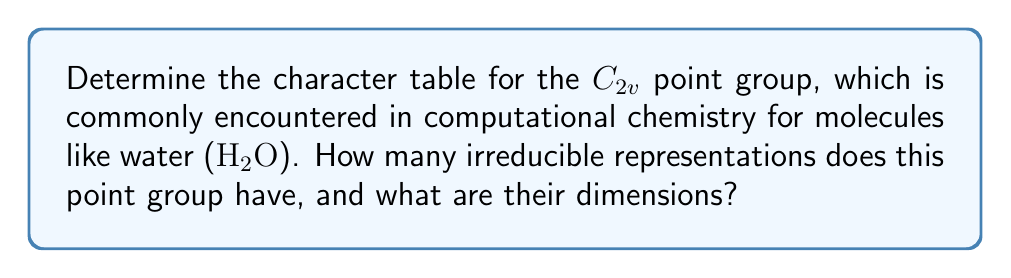Show me your answer to this math problem. To determine the character table for the $C_{2v}$ point group, we'll follow these steps:

1. Identify the symmetry operations:
   - $E$: identity
   - $C_2$: 180° rotation around the z-axis
   - $\sigma_v(xz)$: reflection in the xz-plane
   - $\sigma_v'(yz)$: reflection in the yz-plane

2. Determine the number of classes:
   Each symmetry operation is in its own class, so there are 4 classes.

3. The number of irreducible representations is equal to the number of classes, so there are 4 irreducible representations.

4. Construct the character table:

   $$
   \begin{array}{c|cccc}
   C_{2v} & E & C_2 & \sigma_v(xz) & \sigma_v'(yz) \\
   \hline
   A_1 & 1 & 1 & 1 & 1 \\
   A_2 & 1 & 1 & -1 & -1 \\
   B_1 & 1 & -1 & 1 & -1 \\
   B_2 & 1 & -1 & -1 & 1
   \end{array}
   $$

5. Verify the orthogonality relations:
   The characters in each row and column are orthogonal, satisfying the requirements for a character table.

6. Determine the dimensions of the irreducible representations:
   The dimension of each irreducible representation is given by the character of the identity operation ($E$). In this case, all irreducible representations have a dimension of 1.

[asy]
import geometry;

size(100);
draw(circle((0,0),1));
draw((0,-1)--(0,1),arrow=Arrow(TeXHead));
draw((-1,0)--(1,0),arrow=Arrow(TeXHead));
draw((0,0)--(0.7,0.7),arrow=Arrow(TeXHead));
label("$z$",(0,1.2),N);
label("$y$",(1.2,0),E);
label("$x$",(0.8,0.8),NE);
label("$C_2$",(0,-1.2),S);
label("$\sigma_v(xz)$",(-1.2,0),W);
label("$\sigma_v'(yz)$",(0.7,-0.7),SE);
[/asy]

This diagram illustrates the symmetry elements of the $C_{2v}$ point group.
Answer: 4 irreducible representations, all of dimension 1 